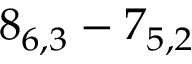<formula> <loc_0><loc_0><loc_500><loc_500>8 _ { 6 , 3 } - 7 _ { 5 , 2 }</formula> 